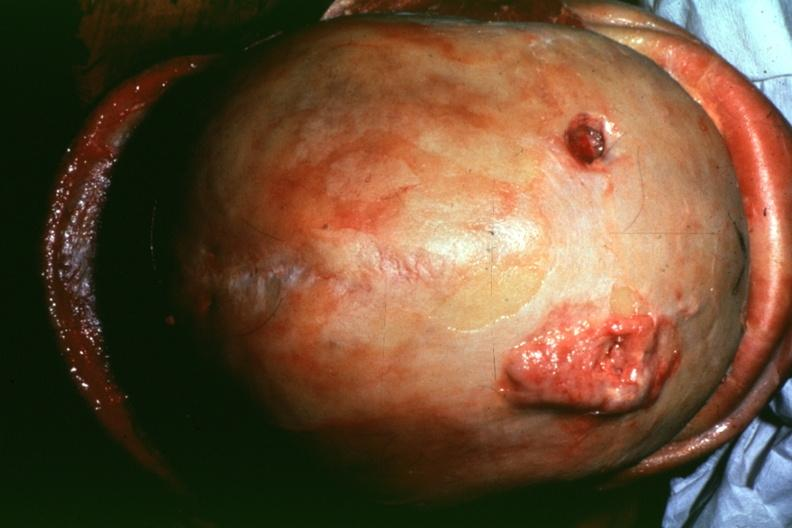s alpha smooth muscle actin immunohistochemical present?
Answer the question using a single word or phrase. No 